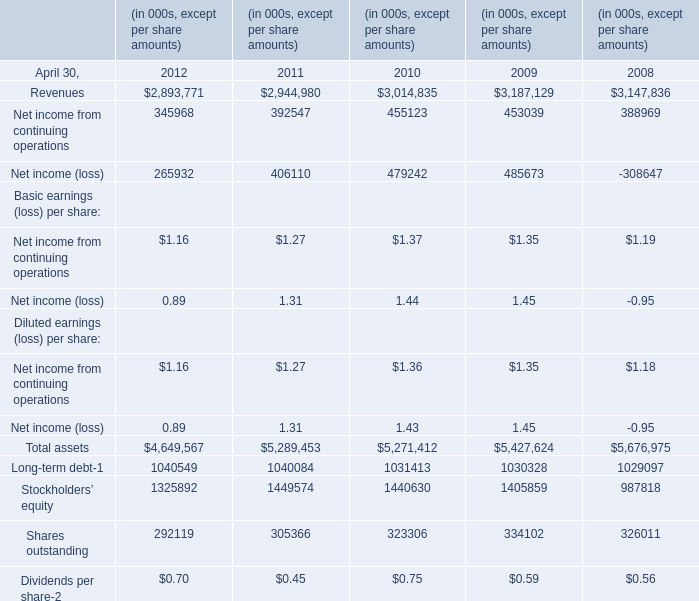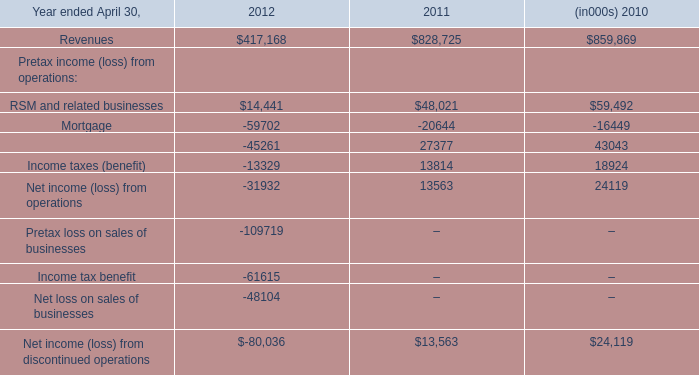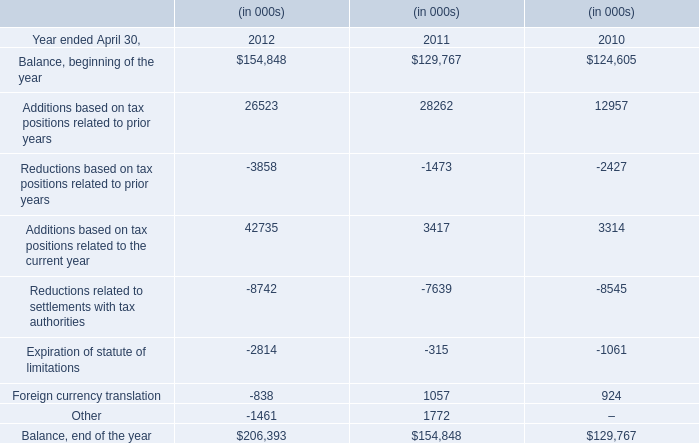what was the percentage reduction in the segment 2019s backlog from 2006 to 2007 
Computations: ((2.6 - 3.2) / 3.2)
Answer: -0.1875. 